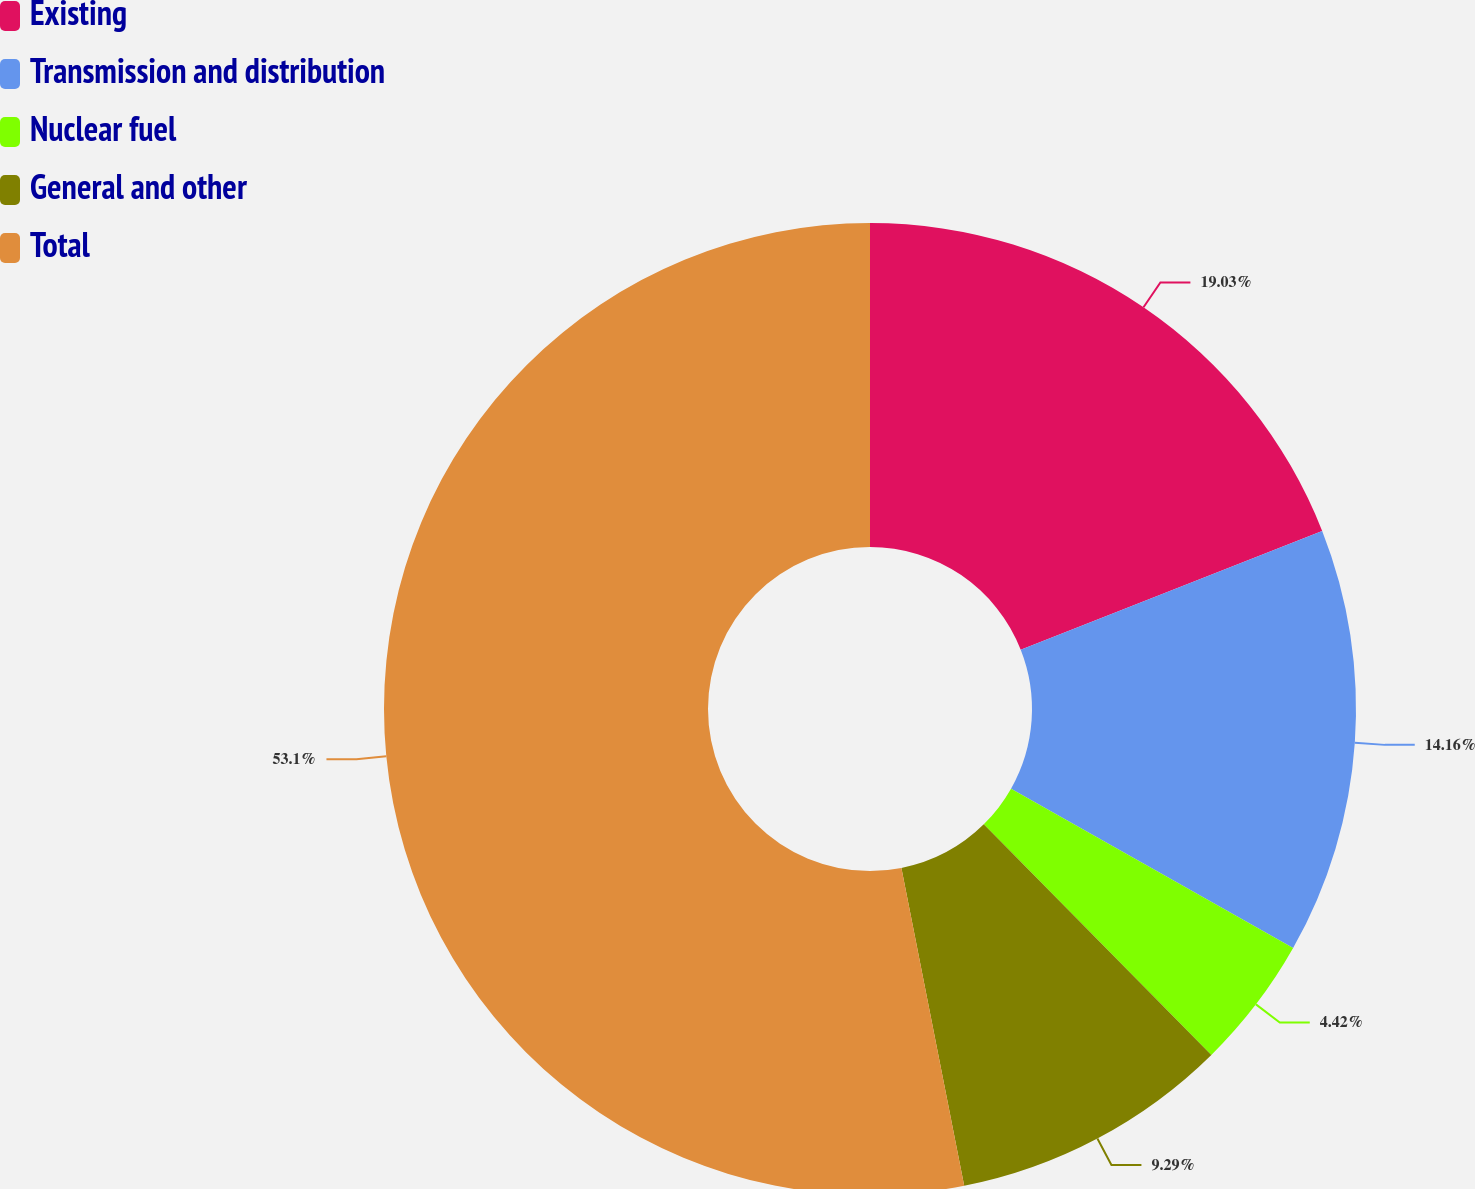<chart> <loc_0><loc_0><loc_500><loc_500><pie_chart><fcel>Existing<fcel>Transmission and distribution<fcel>Nuclear fuel<fcel>General and other<fcel>Total<nl><fcel>19.03%<fcel>14.16%<fcel>4.42%<fcel>9.29%<fcel>53.11%<nl></chart> 